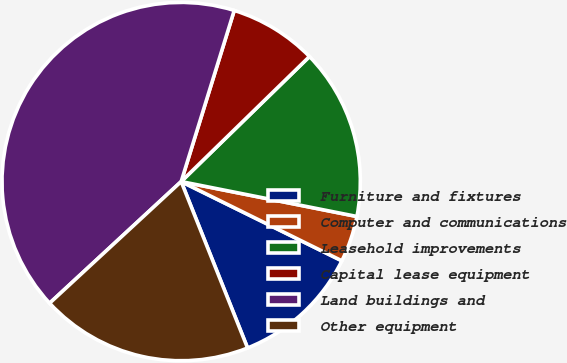Convert chart to OTSL. <chart><loc_0><loc_0><loc_500><loc_500><pie_chart><fcel>Furniture and fixtures<fcel>Computer and communications<fcel>Leasehold improvements<fcel>Capital lease equipment<fcel>Land buildings and<fcel>Other equipment<nl><fcel>11.67%<fcel>4.17%<fcel>15.42%<fcel>7.92%<fcel>41.67%<fcel>19.17%<nl></chart> 